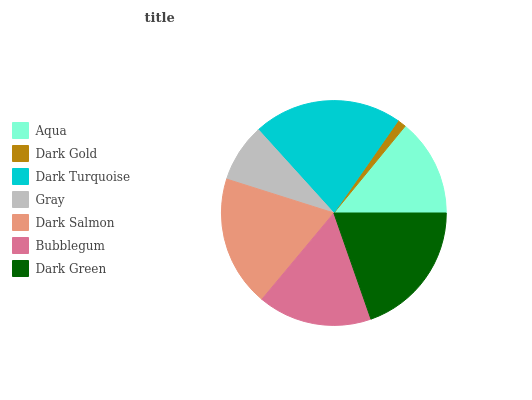Is Dark Gold the minimum?
Answer yes or no. Yes. Is Dark Turquoise the maximum?
Answer yes or no. Yes. Is Dark Turquoise the minimum?
Answer yes or no. No. Is Dark Gold the maximum?
Answer yes or no. No. Is Dark Turquoise greater than Dark Gold?
Answer yes or no. Yes. Is Dark Gold less than Dark Turquoise?
Answer yes or no. Yes. Is Dark Gold greater than Dark Turquoise?
Answer yes or no. No. Is Dark Turquoise less than Dark Gold?
Answer yes or no. No. Is Bubblegum the high median?
Answer yes or no. Yes. Is Bubblegum the low median?
Answer yes or no. Yes. Is Dark Green the high median?
Answer yes or no. No. Is Dark Green the low median?
Answer yes or no. No. 